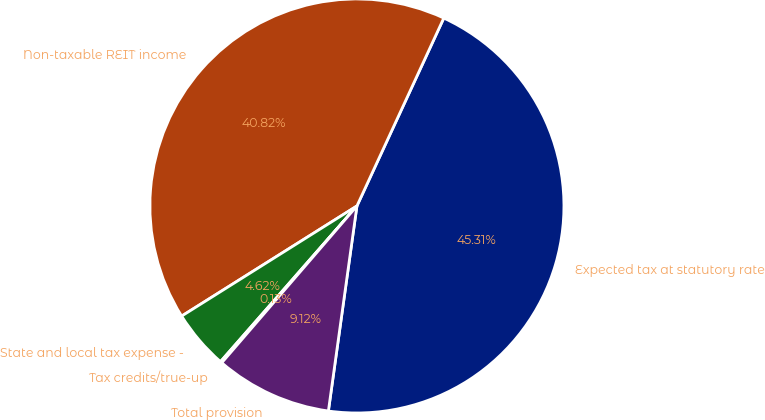Convert chart to OTSL. <chart><loc_0><loc_0><loc_500><loc_500><pie_chart><fcel>Expected tax at statutory rate<fcel>Non-taxable REIT income<fcel>State and local tax expense -<fcel>Tax credits/true-up<fcel>Total provision<nl><fcel>45.31%<fcel>40.82%<fcel>4.62%<fcel>0.13%<fcel>9.12%<nl></chart> 